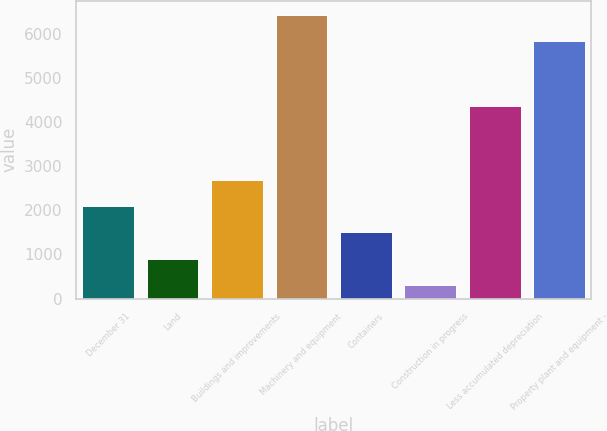<chart> <loc_0><loc_0><loc_500><loc_500><bar_chart><fcel>December 31<fcel>Land<fcel>Buildings and improvements<fcel>Machinery and equipment<fcel>Containers<fcel>Construction in progress<fcel>Less accumulated depreciation<fcel>Property plant and equipment -<nl><fcel>2095.5<fcel>902.5<fcel>2692<fcel>6427.5<fcel>1499<fcel>306<fcel>4353<fcel>5831<nl></chart> 